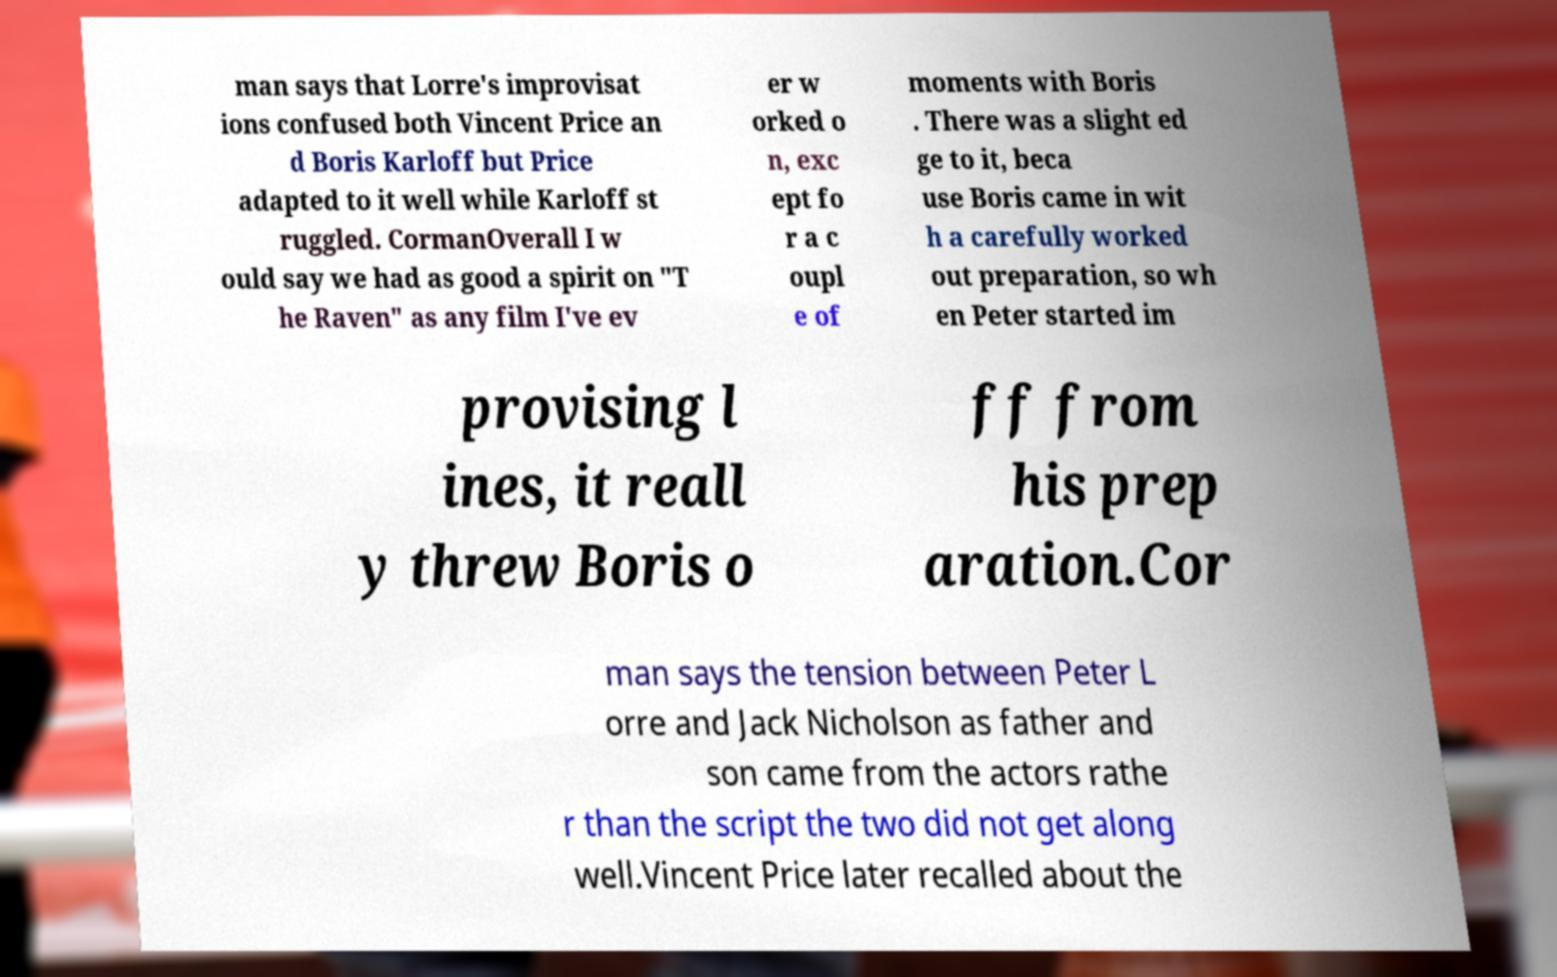Can you accurately transcribe the text from the provided image for me? man says that Lorre's improvisat ions confused both Vincent Price an d Boris Karloff but Price adapted to it well while Karloff st ruggled. CormanOverall I w ould say we had as good a spirit on "T he Raven" as any film I've ev er w orked o n, exc ept fo r a c oupl e of moments with Boris . There was a slight ed ge to it, beca use Boris came in wit h a carefully worked out preparation, so wh en Peter started im provising l ines, it reall y threw Boris o ff from his prep aration.Cor man says the tension between Peter L orre and Jack Nicholson as father and son came from the actors rathe r than the script the two did not get along well.Vincent Price later recalled about the 